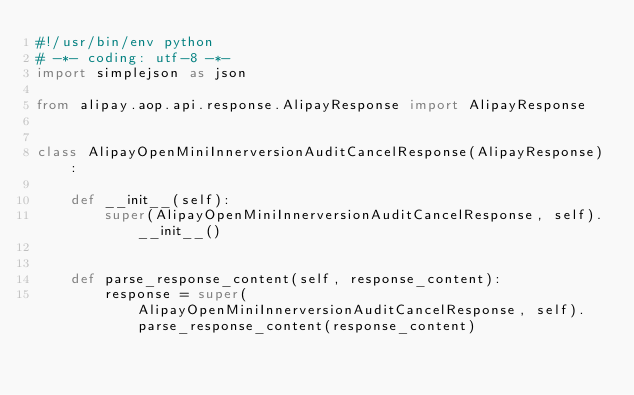Convert code to text. <code><loc_0><loc_0><loc_500><loc_500><_Python_>#!/usr/bin/env python
# -*- coding: utf-8 -*-
import simplejson as json

from alipay.aop.api.response.AlipayResponse import AlipayResponse


class AlipayOpenMiniInnerversionAuditCancelResponse(AlipayResponse):

    def __init__(self):
        super(AlipayOpenMiniInnerversionAuditCancelResponse, self).__init__()


    def parse_response_content(self, response_content):
        response = super(AlipayOpenMiniInnerversionAuditCancelResponse, self).parse_response_content(response_content)
</code> 